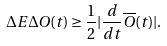<formula> <loc_0><loc_0><loc_500><loc_500>\Delta E \Delta O ( t ) \geq \frac { 1 } { 2 } | \frac { d } { d t } \overline { O } ( t ) | .</formula> 